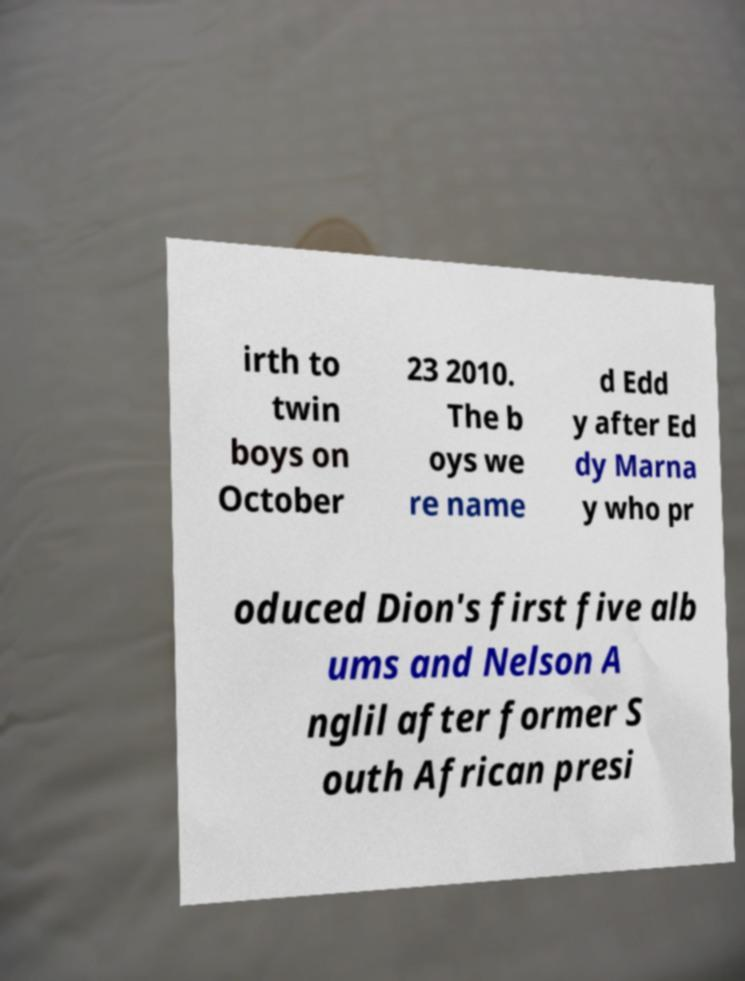For documentation purposes, I need the text within this image transcribed. Could you provide that? irth to twin boys on October 23 2010. The b oys we re name d Edd y after Ed dy Marna y who pr oduced Dion's first five alb ums and Nelson A nglil after former S outh African presi 